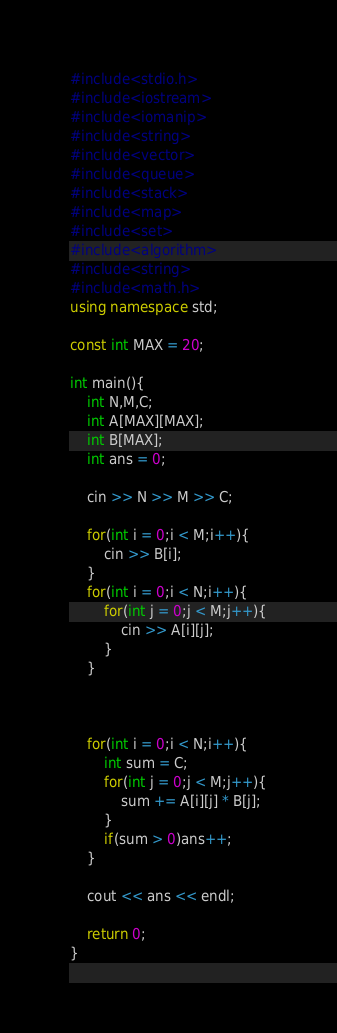Convert code to text. <code><loc_0><loc_0><loc_500><loc_500><_C++_>#include<stdio.h>
#include<iostream>
#include<iomanip>
#include<string>
#include<vector>
#include<queue>
#include<stack>
#include<map>
#include<set>
#include<algorithm>
#include<string>
#include<math.h>
using namespace std;
 
const int MAX = 20;
 
int main(){
    int N,M,C;
    int A[MAX][MAX];
    int B[MAX];
    int ans = 0;
 
    cin >> N >> M >> C;
    
    for(int i = 0;i < M;i++){
        cin >> B[i];
    }
    for(int i = 0;i < N;i++){
        for(int j = 0;j < M;j++){
            cin >> A[i][j];
        }
    }
 
 
 
    for(int i = 0;i < N;i++){
        int sum = C;
        for(int j = 0;j < M;j++){
            sum += A[i][j] * B[j];
        }
        if(sum > 0)ans++;
    }
 
    cout << ans << endl;
 
    return 0;
}</code> 